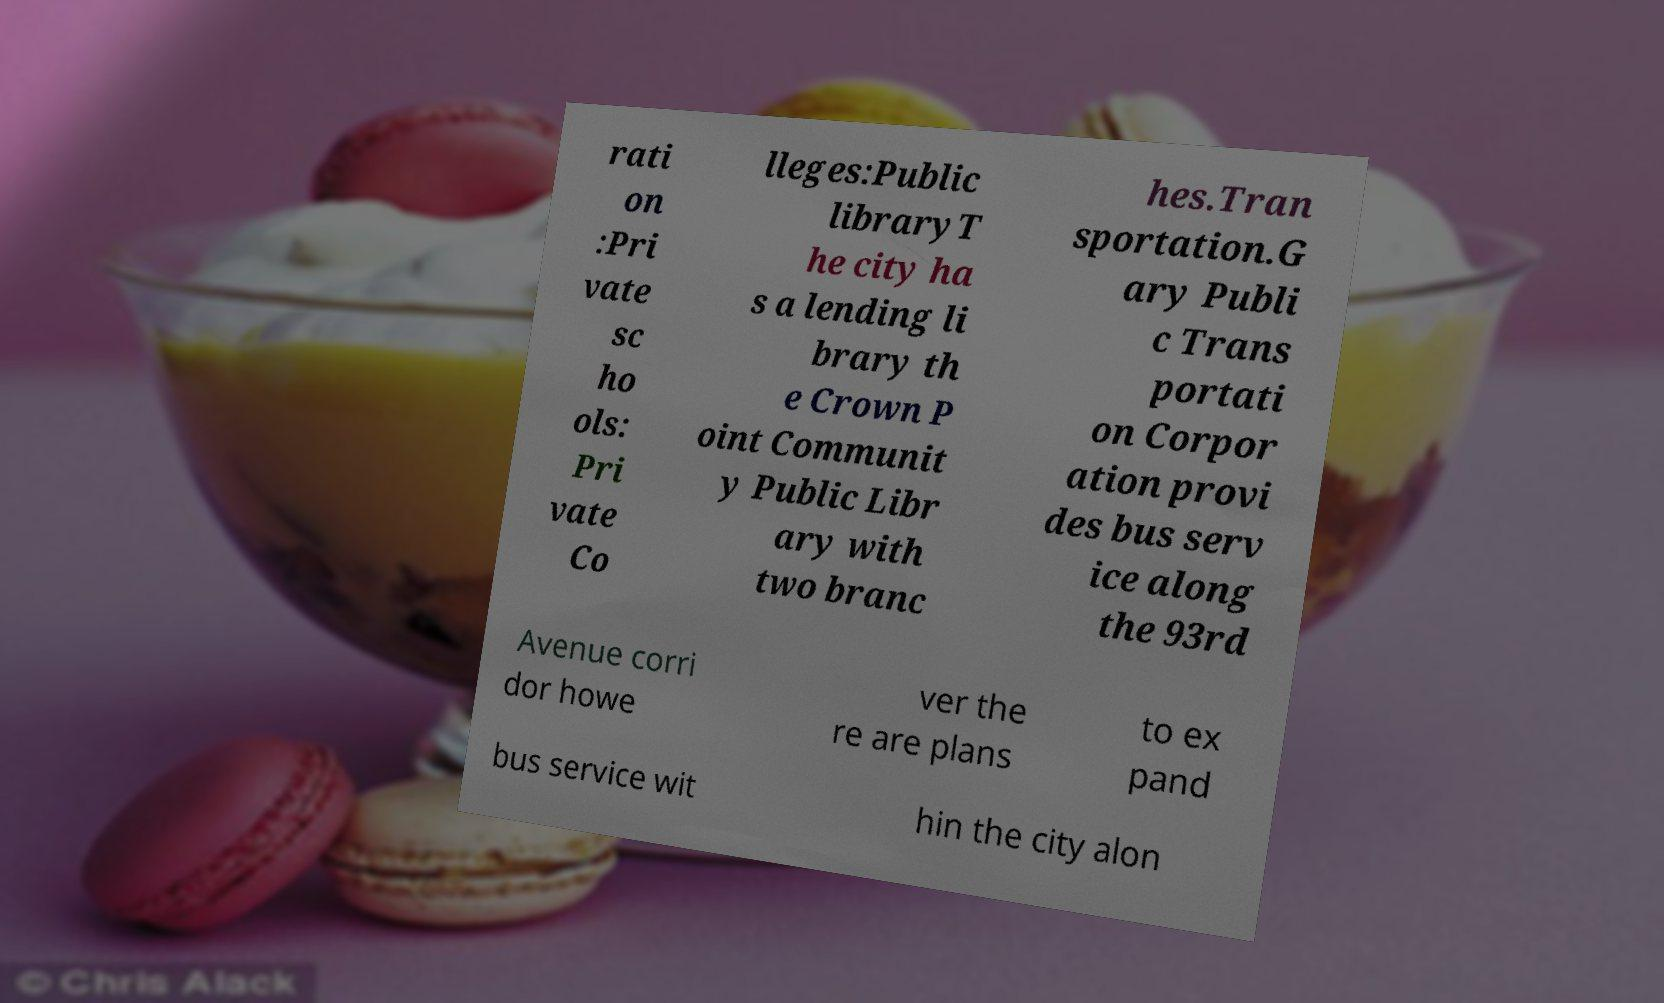Can you accurately transcribe the text from the provided image for me? rati on :Pri vate sc ho ols: Pri vate Co lleges:Public libraryT he city ha s a lending li brary th e Crown P oint Communit y Public Libr ary with two branc hes.Tran sportation.G ary Publi c Trans portati on Corpor ation provi des bus serv ice along the 93rd Avenue corri dor howe ver the re are plans to ex pand bus service wit hin the city alon 